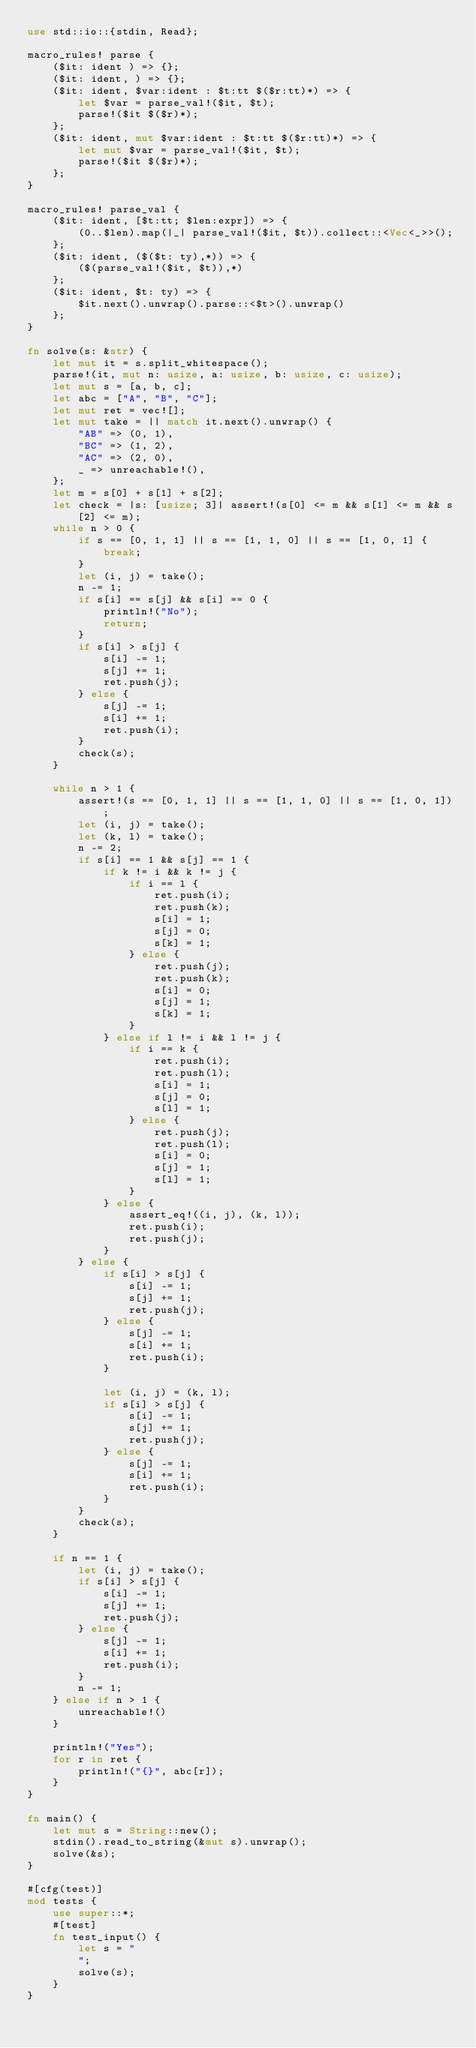Convert code to text. <code><loc_0><loc_0><loc_500><loc_500><_Rust_>use std::io::{stdin, Read};

macro_rules! parse {
    ($it: ident ) => {};
    ($it: ident, ) => {};
    ($it: ident, $var:ident : $t:tt $($r:tt)*) => {
        let $var = parse_val!($it, $t);
        parse!($it $($r)*);
    };
    ($it: ident, mut $var:ident : $t:tt $($r:tt)*) => {
        let mut $var = parse_val!($it, $t);
        parse!($it $($r)*);
    };
}

macro_rules! parse_val {
    ($it: ident, [$t:tt; $len:expr]) => {
        (0..$len).map(|_| parse_val!($it, $t)).collect::<Vec<_>>();
    };
    ($it: ident, ($($t: ty),*)) => {
        ($(parse_val!($it, $t)),*)
    };
    ($it: ident, $t: ty) => {
        $it.next().unwrap().parse::<$t>().unwrap()
    };
}

fn solve(s: &str) {
    let mut it = s.split_whitespace();
    parse!(it, mut n: usize, a: usize, b: usize, c: usize);
    let mut s = [a, b, c];
    let abc = ["A", "B", "C"];
    let mut ret = vec![];
    let mut take = || match it.next().unwrap() {
        "AB" => (0, 1),
        "BC" => (1, 2),
        "AC" => (2, 0),
        _ => unreachable!(),
    };
    let m = s[0] + s[1] + s[2];
    let check = |s: [usize; 3]| assert!(s[0] <= m && s[1] <= m && s[2] <= m);
    while n > 0 {
        if s == [0, 1, 1] || s == [1, 1, 0] || s == [1, 0, 1] {
            break;
        }
        let (i, j) = take();
        n -= 1;
        if s[i] == s[j] && s[i] == 0 {
            println!("No");
            return;
        }
        if s[i] > s[j] {
            s[i] -= 1;
            s[j] += 1;
            ret.push(j);
        } else {
            s[j] -= 1;
            s[i] += 1;
            ret.push(i);
        }
        check(s);
    }

    while n > 1 {
        assert!(s == [0, 1, 1] || s == [1, 1, 0] || s == [1, 0, 1]);
        let (i, j) = take();
        let (k, l) = take();
        n -= 2;
        if s[i] == 1 && s[j] == 1 {
            if k != i && k != j {
                if i == l {
                    ret.push(i);
                    ret.push(k);
                    s[i] = 1;
                    s[j] = 0;
                    s[k] = 1;
                } else {
                    ret.push(j);
                    ret.push(k);
                    s[i] = 0;
                    s[j] = 1;
                    s[k] = 1;
                }
            } else if l != i && l != j {
                if i == k {
                    ret.push(i);
                    ret.push(l);
                    s[i] = 1;
                    s[j] = 0;
                    s[l] = 1;
                } else {
                    ret.push(j);
                    ret.push(l);
                    s[i] = 0;
                    s[j] = 1;
                    s[l] = 1;
                }
            } else {
                assert_eq!((i, j), (k, l));
                ret.push(i);
                ret.push(j);
            }
        } else {
            if s[i] > s[j] {
                s[i] -= 1;
                s[j] += 1;
                ret.push(j);
            } else {
                s[j] -= 1;
                s[i] += 1;
                ret.push(i);
            }

            let (i, j) = (k, l);
            if s[i] > s[j] {
                s[i] -= 1;
                s[j] += 1;
                ret.push(j);
            } else {
                s[j] -= 1;
                s[i] += 1;
                ret.push(i);
            }
        }
        check(s);
    }

    if n == 1 {
        let (i, j) = take();
        if s[i] > s[j] {
            s[i] -= 1;
            s[j] += 1;
            ret.push(j);
        } else {
            s[j] -= 1;
            s[i] += 1;
            ret.push(i);
        }
        n -= 1;
    } else if n > 1 {
        unreachable!()
    }

    println!("Yes");
    for r in ret {
        println!("{}", abc[r]);
    }
}

fn main() {
    let mut s = String::new();
    stdin().read_to_string(&mut s).unwrap();
    solve(&s);
}

#[cfg(test)]
mod tests {
    use super::*;
    #[test]
    fn test_input() {
        let s = "
        ";
        solve(s);
    }
}
</code> 